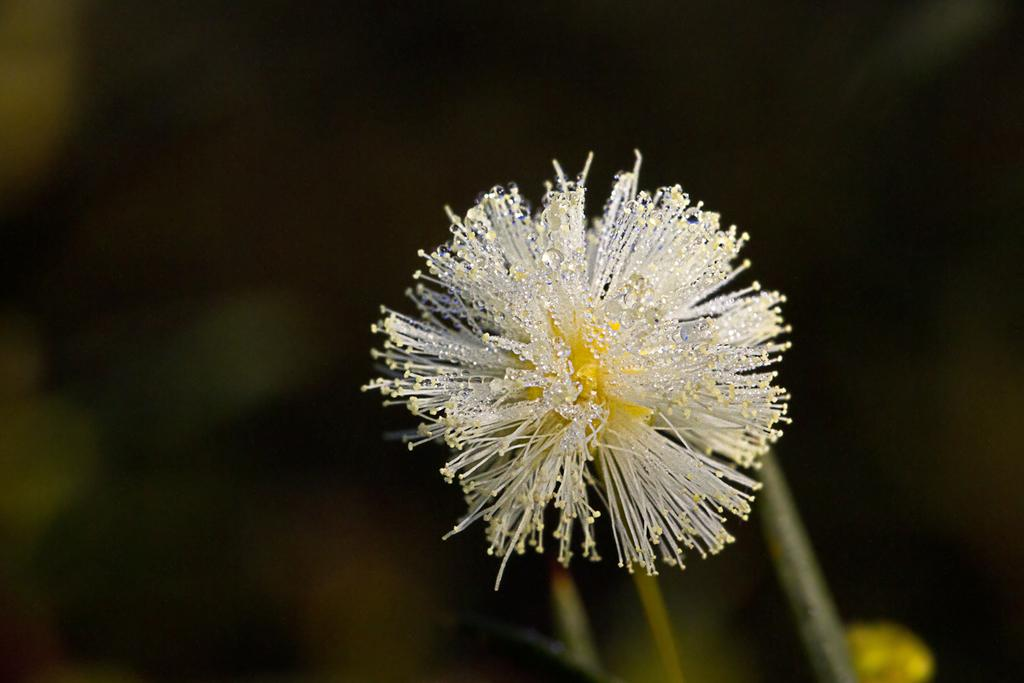What is the main subject of the image? There is a flower in the image. Can you describe the background of the image? The background of the image is blurry. How many kittens are playing with a heart-shaped toy in the image? There are no kittens or heart-shaped toys present in the image; it features a flower with a blurry background. 